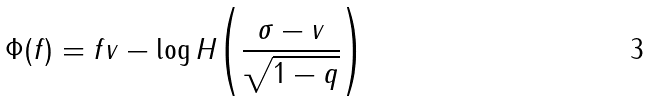Convert formula to latex. <formula><loc_0><loc_0><loc_500><loc_500>\Phi ( f ) = f v - \log H { \left ( \frac { \sigma - v } { \sqrt { 1 - q } } \right ) }</formula> 